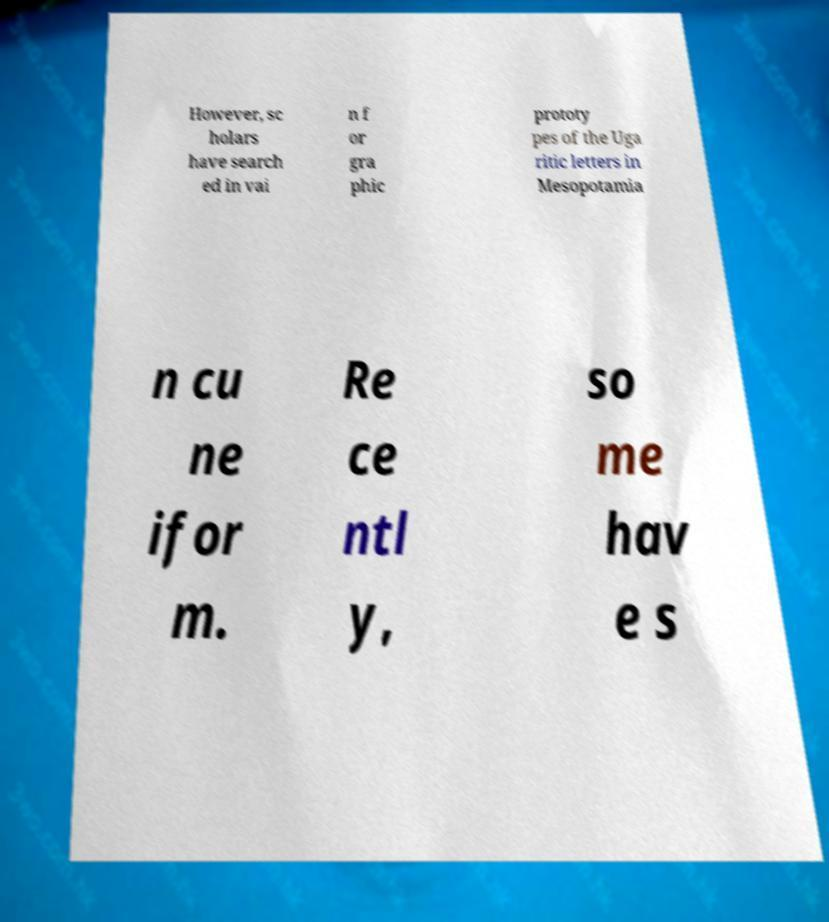Can you read and provide the text displayed in the image?This photo seems to have some interesting text. Can you extract and type it out for me? However, sc holars have search ed in vai n f or gra phic prototy pes of the Uga ritic letters in Mesopotamia n cu ne ifor m. Re ce ntl y, so me hav e s 